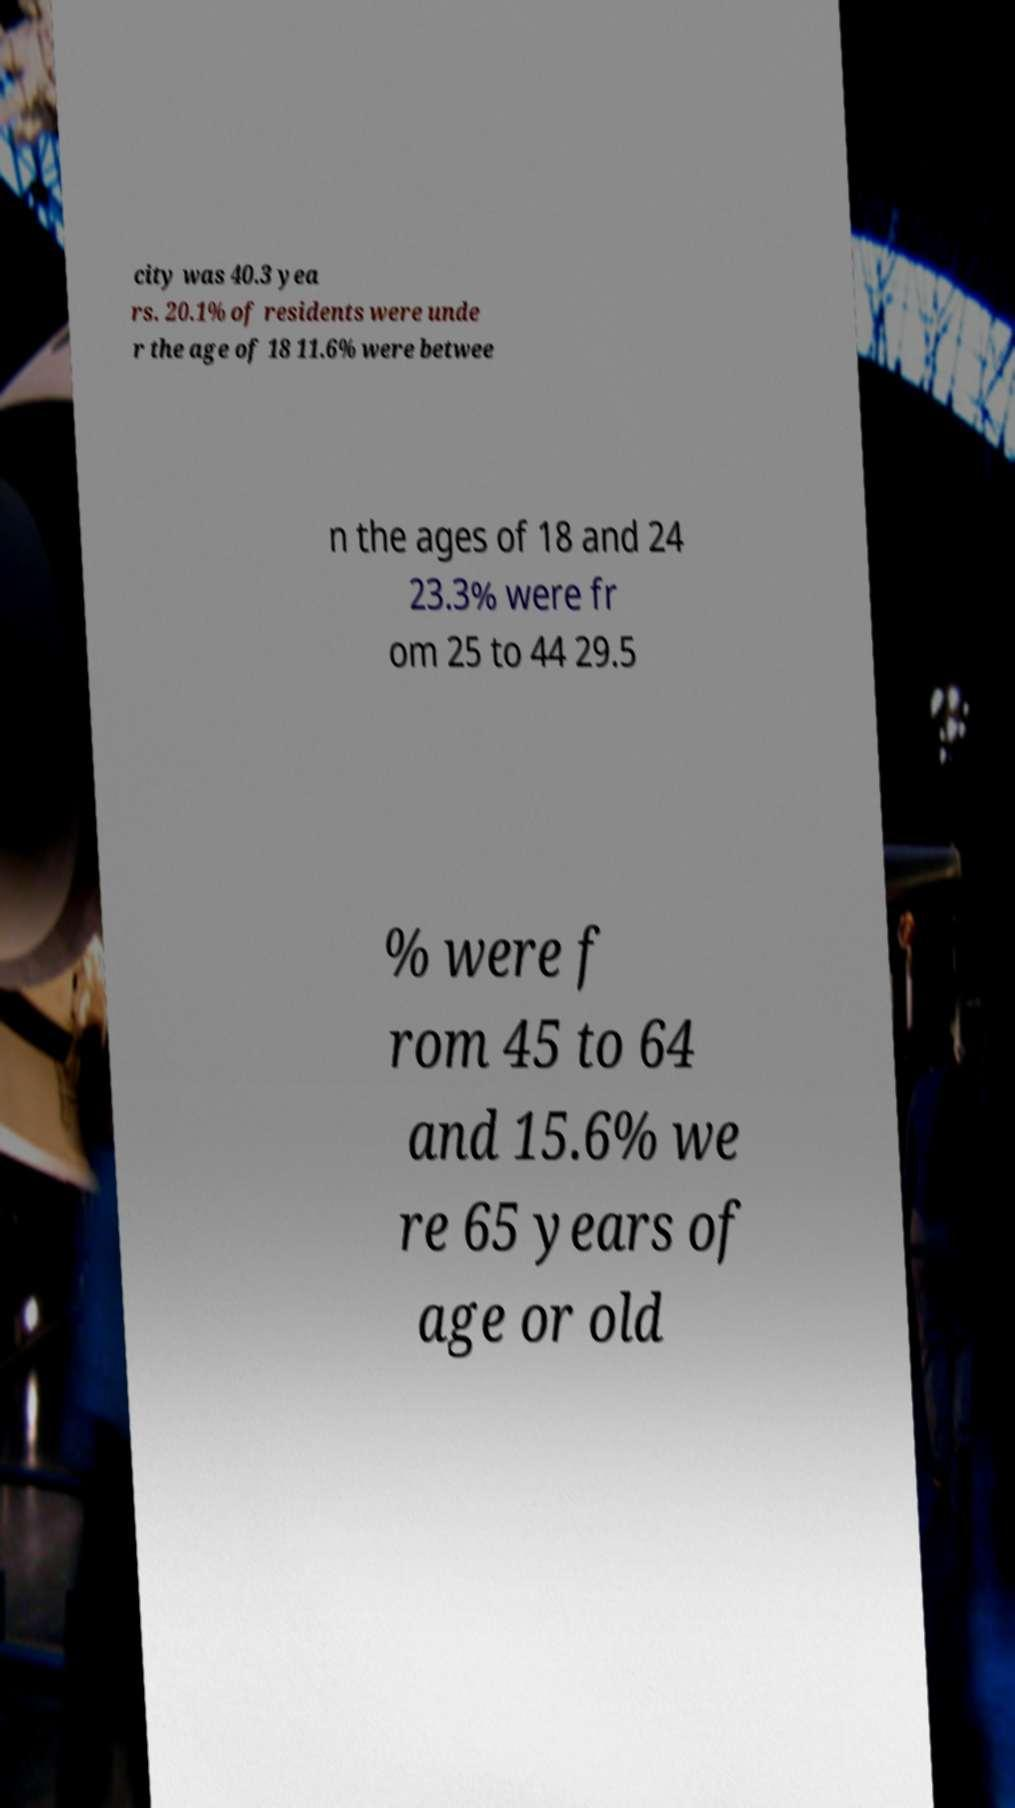For documentation purposes, I need the text within this image transcribed. Could you provide that? city was 40.3 yea rs. 20.1% of residents were unde r the age of 18 11.6% were betwee n the ages of 18 and 24 23.3% were fr om 25 to 44 29.5 % were f rom 45 to 64 and 15.6% we re 65 years of age or old 